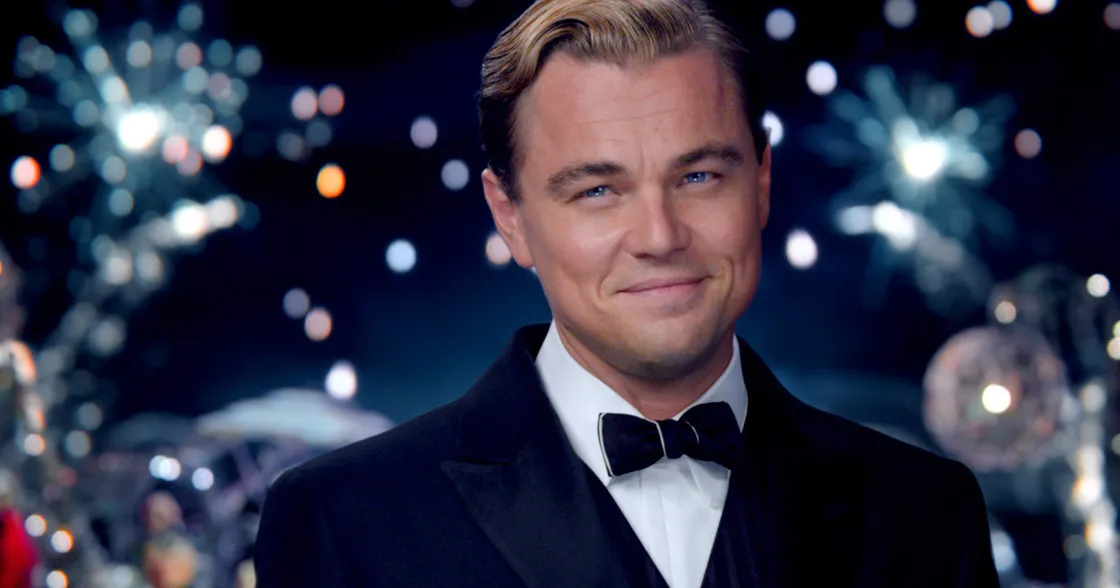If you could imagine a backstory for this character, what would it be? The character might have risen from humble beginnings to achieve great success and wealth. His elegant attire and the luxurious party setting suggest he enjoys the finer things in life, possibly as a way to escape or make up for a tumultuous past. His slight smile and direct gaze hint at a character who is both charming and enigmatic, someone who has carefully built his image and reputation through persistence and charisma. Behind the confident exterior, there could be a complex individual with a longing for genuine connection and fulfillment. 